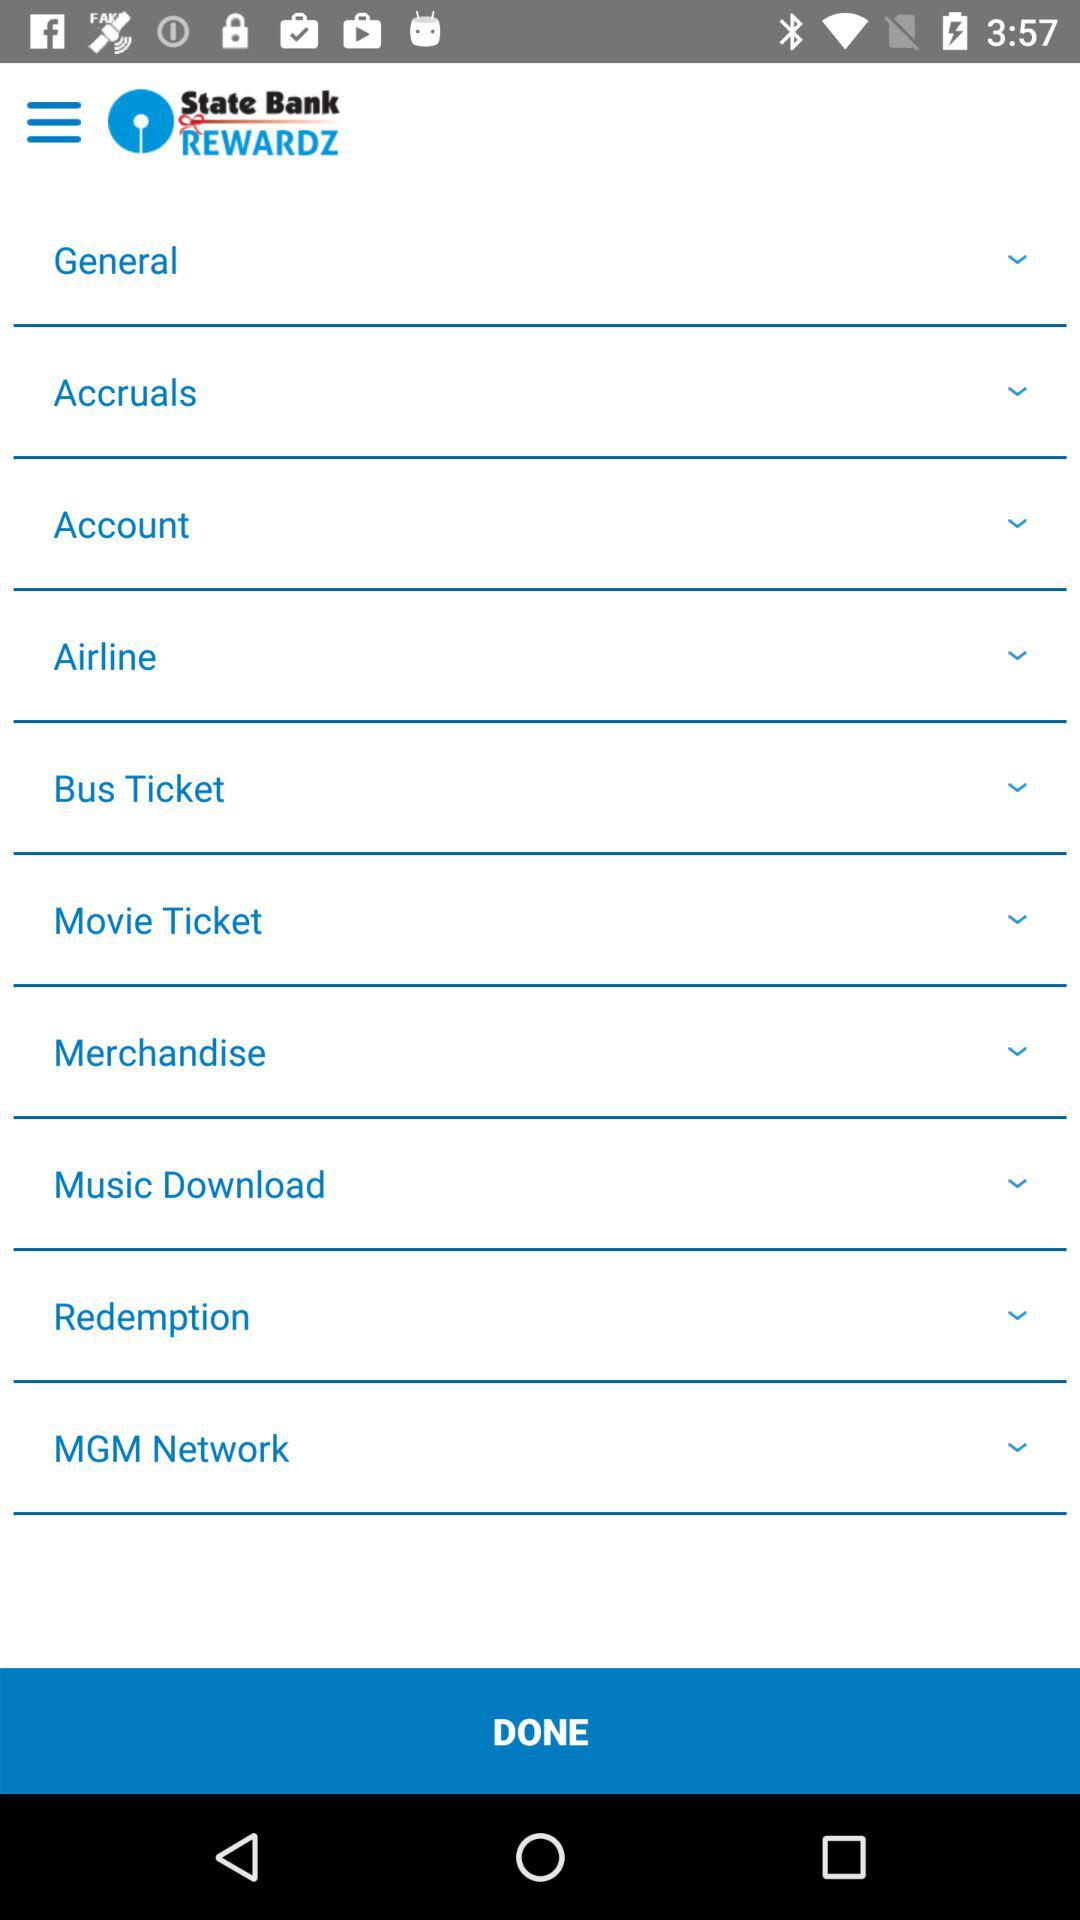What is the application name? The application name is "State Bank REWARDZ". 